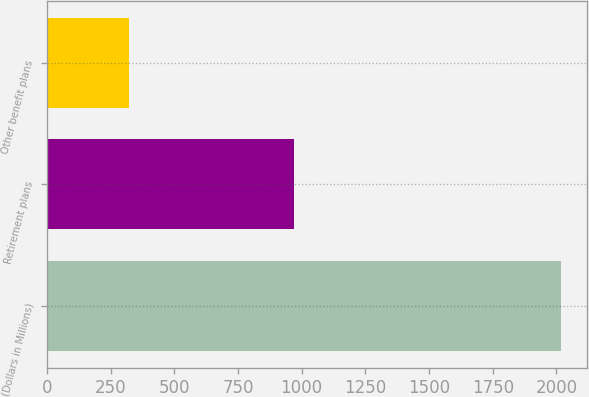<chart> <loc_0><loc_0><loc_500><loc_500><bar_chart><fcel>(Dollars in Millions)<fcel>Retirement plans<fcel>Other benefit plans<nl><fcel>2018<fcel>970<fcel>322<nl></chart> 